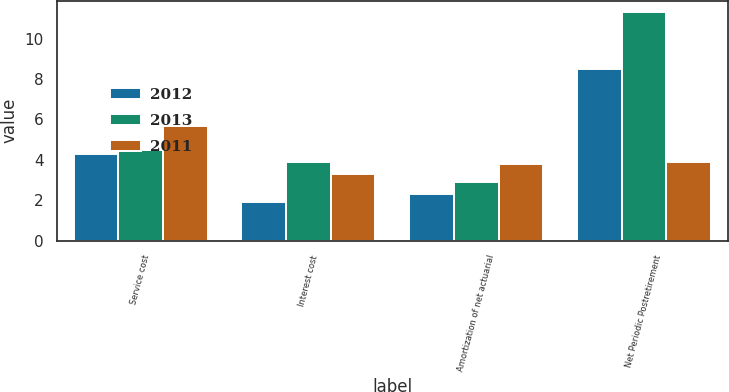Convert chart to OTSL. <chart><loc_0><loc_0><loc_500><loc_500><stacked_bar_chart><ecel><fcel>Service cost<fcel>Interest cost<fcel>Amortization of net actuarial<fcel>Net Periodic Postretirement<nl><fcel>2012<fcel>4.3<fcel>1.9<fcel>2.3<fcel>8.5<nl><fcel>2013<fcel>4.5<fcel>3.9<fcel>2.9<fcel>11.3<nl><fcel>2011<fcel>5.7<fcel>3.3<fcel>3.8<fcel>3.9<nl></chart> 